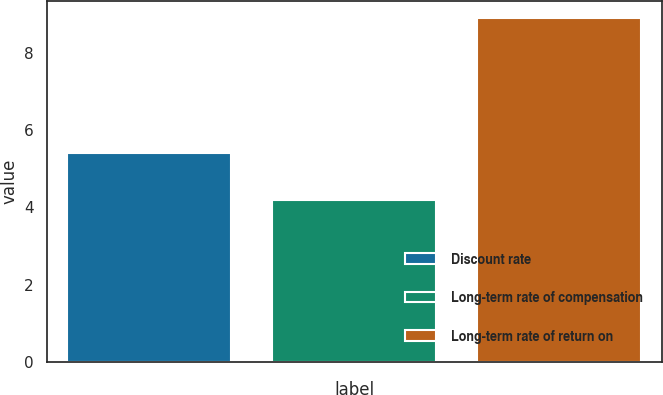Convert chart to OTSL. <chart><loc_0><loc_0><loc_500><loc_500><bar_chart><fcel>Discount rate<fcel>Long-term rate of compensation<fcel>Long-term rate of return on<nl><fcel>5.4<fcel>4.2<fcel>8.9<nl></chart> 